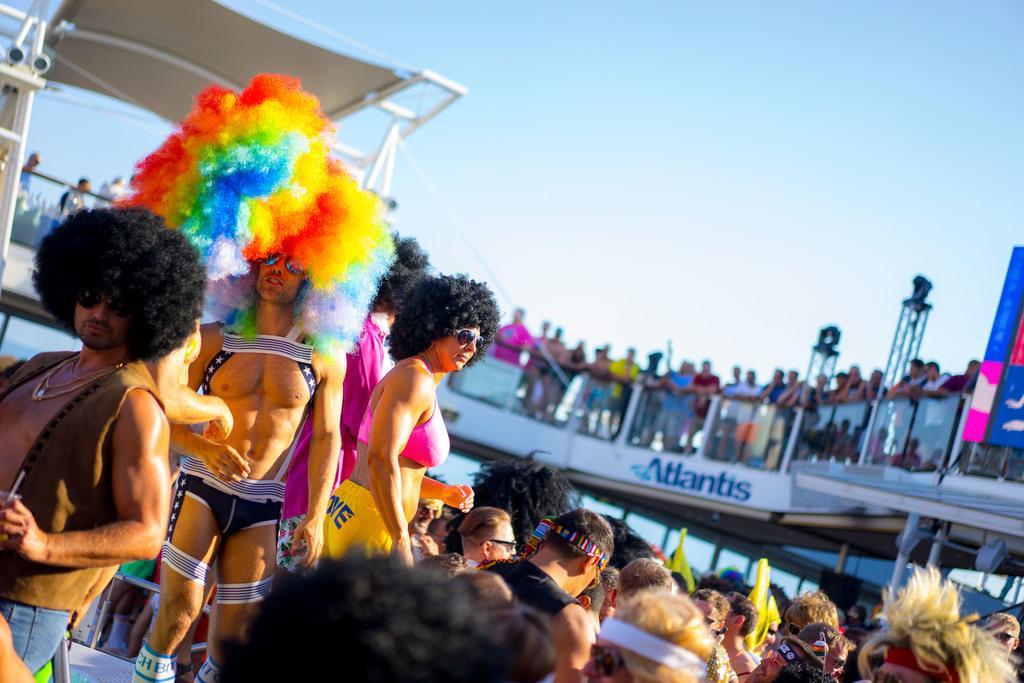In one or two sentences, can you explain what this image depicts? In this image I can see some people. I can see a board with some text written on it. At the top I can see the sky. 